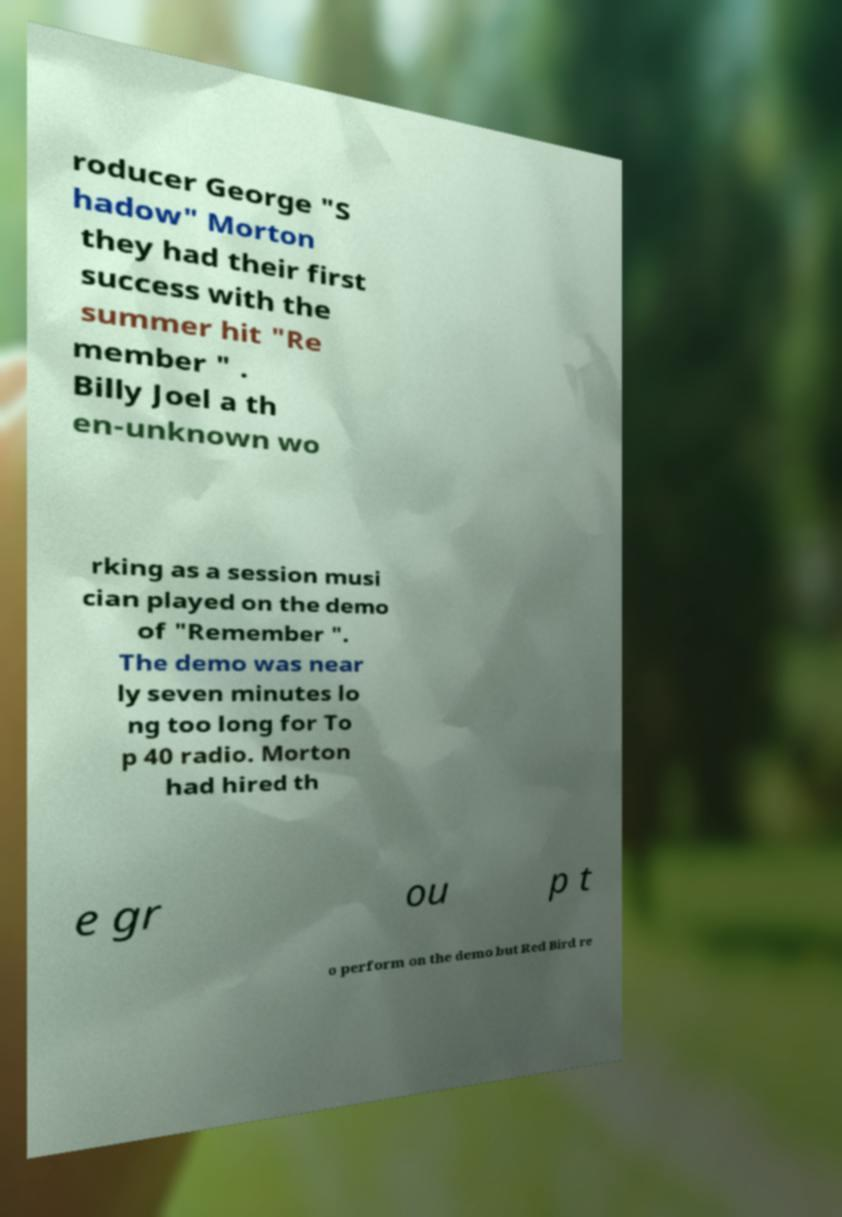Please read and relay the text visible in this image. What does it say? roducer George "S hadow" Morton they had their first success with the summer hit "Re member " . Billy Joel a th en-unknown wo rking as a session musi cian played on the demo of "Remember ". The demo was near ly seven minutes lo ng too long for To p 40 radio. Morton had hired th e gr ou p t o perform on the demo but Red Bird re 